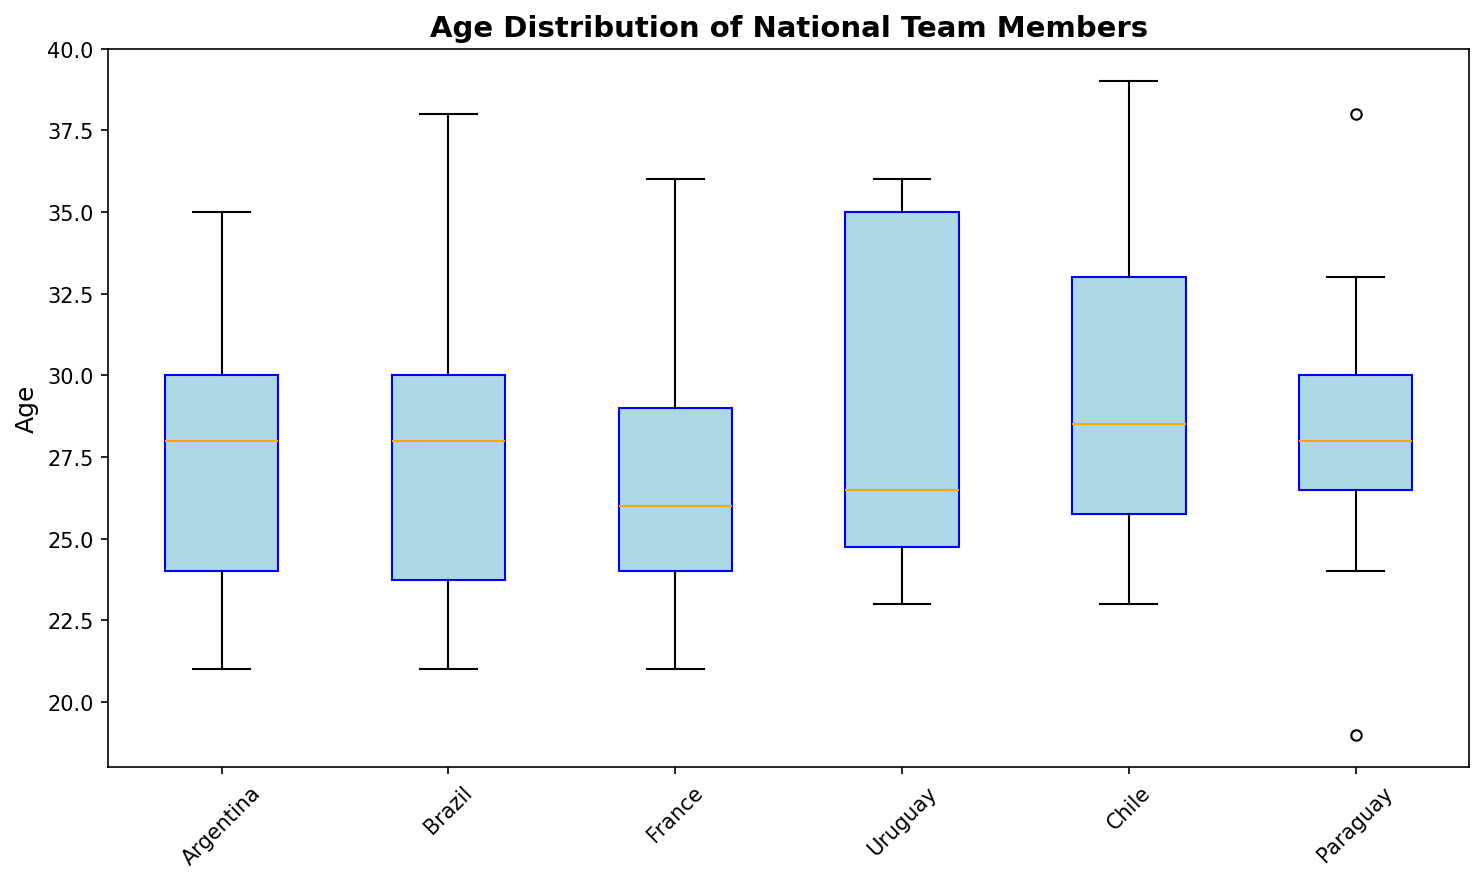What is the median age of the Argentine national team? To find the median age, locate the middle value in the sorted list of ages for the Argentine national team. The ages in ascending order are 21, 22, 23, 24, 24, 24, 26, 26, 28, 28, 29, 30, 30, 34, 34, 34, 35. The middle value is the 9th value, which is 28.
Answer: 28 Which team has the highest median age? By examining the position of the median line in each team's box plot, the team with the highest median age is the one where the median line is the highest on the age axis.
Answer: Uruguay How does the age range of the Argentine team compare to the Brazilian team? The range is the difference between the minimum and maximum ages in each team's box. For Argentina, the range is 35-21=14. For Brazil, the range is 38-21=17. Therefore, Brazil has a wider age range.
Answer: Brazil has a wider age range Which team has the youngest player, and what is their age? The youngest player is indicated by the lowest point (lowest whisker or outlier) on the age axis. The youngest player is from Paraguay with an age of 19.
Answer: Paraguay, 19 Is the median age of the French team higher than that of the Chilean team? Compare the median line of the French team’s box plot with the median line of the Chilean team’s box plot. The median age of the French team is approximately 26, while that of the Chilean team is around 30.
Answer: No Do more teams have a median age above or below 30? Count the number of teams where the median marker (usually an orange line) is above or below the 30-year mark on the age axis. There are more teams with the median age below 30.
Answer: Below 30 Which team has the largest interquartile range (IQR), and what does this suggest? The interquartile range can be observed by the height of the box. The team with the largest IQR has the tallest box. Uruguay has the largest IQR, suggesting the most variability in player age.
Answer: Uruguay, most variability Which team has the smallest interquartile range (IQR)? The smallest IQR corresponds to the team with the shortest box. Argentina has the smallest IQR.
Answer: Argentina What is the oldest age found in the Uruguay national team? The oldest age in a team is indicated by the top whisker’s endpoint or the highest outlier. For Uruguay, the oldest age is 36.
Answer: 36 